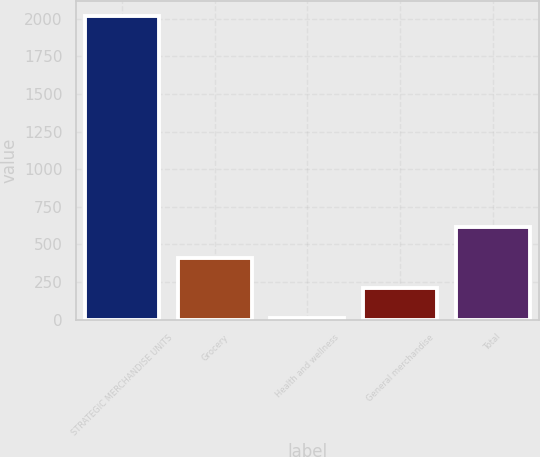<chart> <loc_0><loc_0><loc_500><loc_500><bar_chart><fcel>STRATEGIC MERCHANDISE UNITS<fcel>Grocery<fcel>Health and wellness<fcel>General merchandise<fcel>Total<nl><fcel>2016<fcel>412<fcel>11<fcel>211.5<fcel>612.5<nl></chart> 